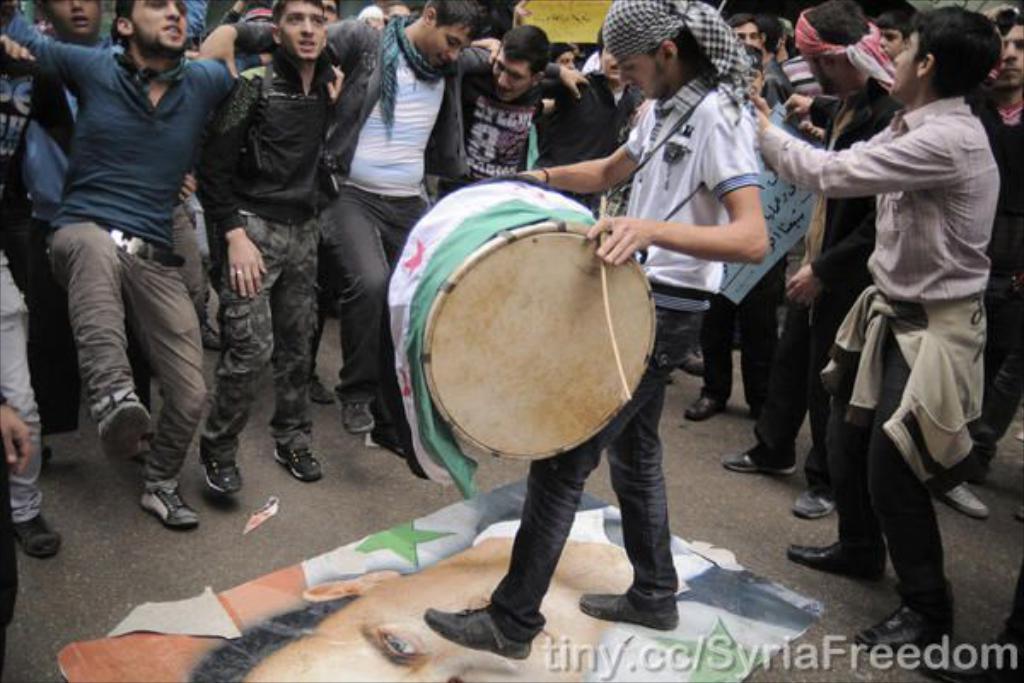In one or two sentences, can you explain what this image depicts? In this picture there is a guy playing drums with sticks standing on photo of some person on the floor. In the background there are some people dancing for his drums here. 